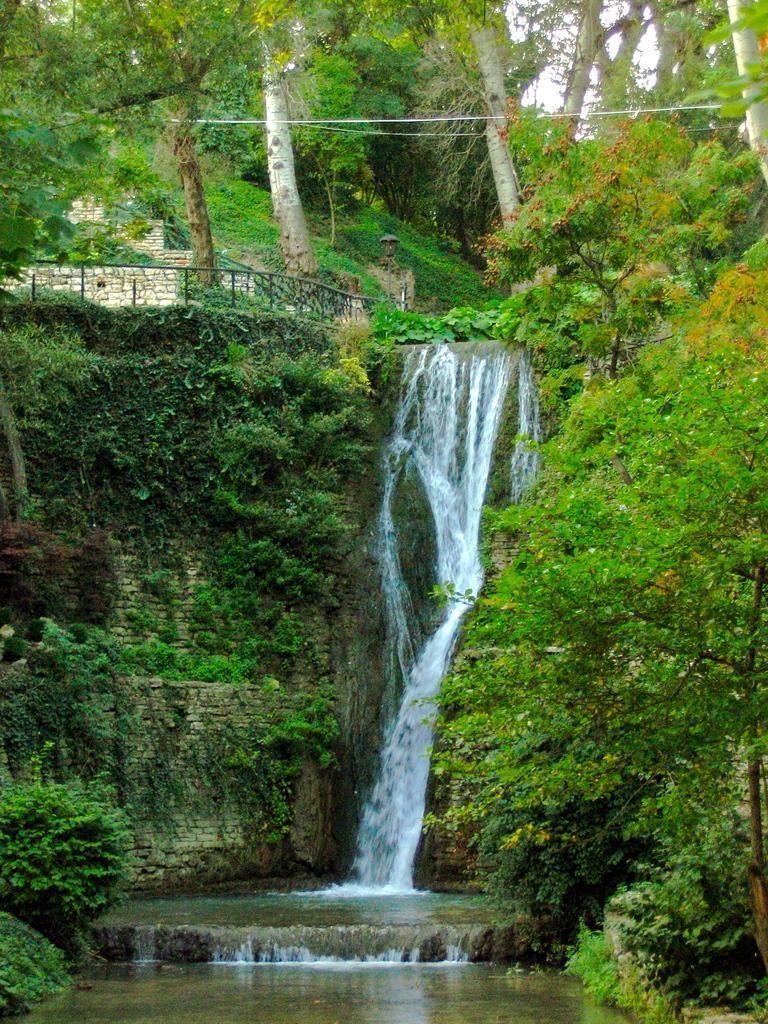Please provide a concise description of this image. In this image we can see the waterfall. And we can see the plants and trees. And we can see the metal railing. And we can see the sky. 